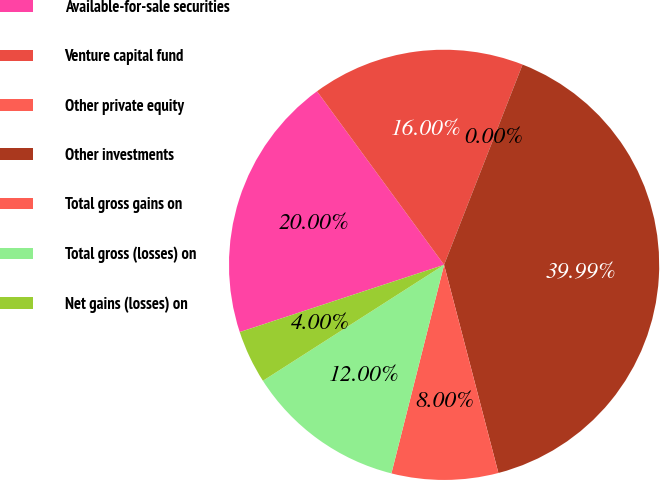Convert chart to OTSL. <chart><loc_0><loc_0><loc_500><loc_500><pie_chart><fcel>Available-for-sale securities<fcel>Venture capital fund<fcel>Other private equity<fcel>Other investments<fcel>Total gross gains on<fcel>Total gross (losses) on<fcel>Net gains (losses) on<nl><fcel>20.0%<fcel>16.0%<fcel>0.0%<fcel>39.99%<fcel>8.0%<fcel>12.0%<fcel>4.0%<nl></chart> 